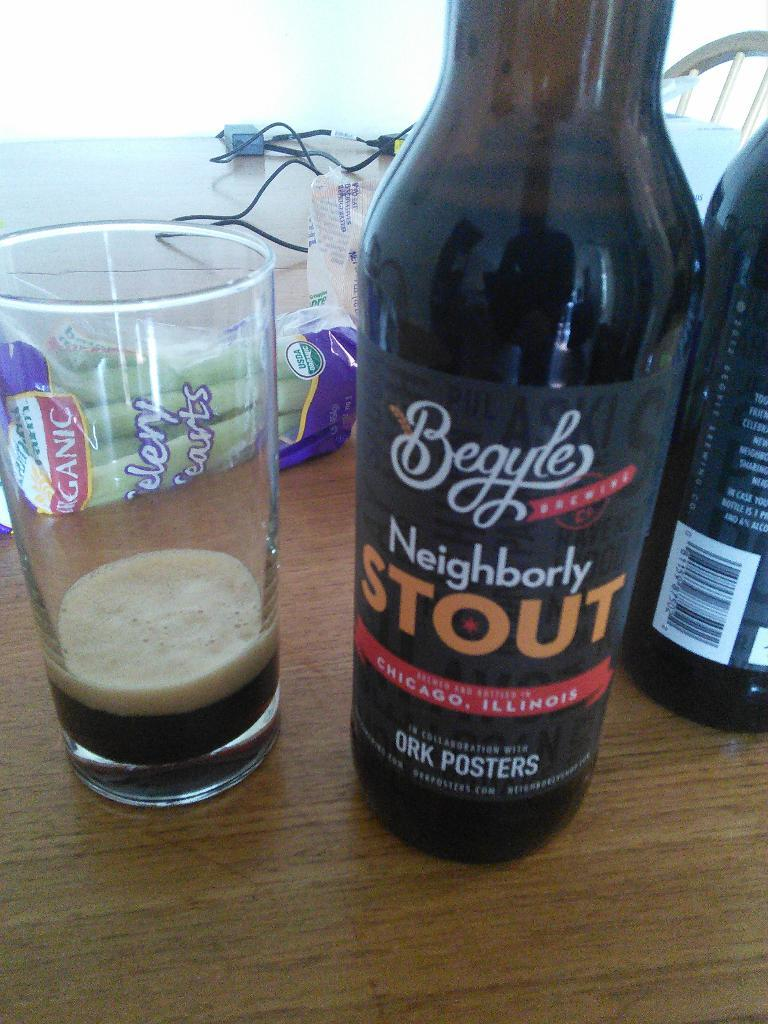<image>
Summarize the visual content of the image. A bottle of Neighborly Stout brewed in Chicago sits on a table next to an almost empty glass of the beer. 